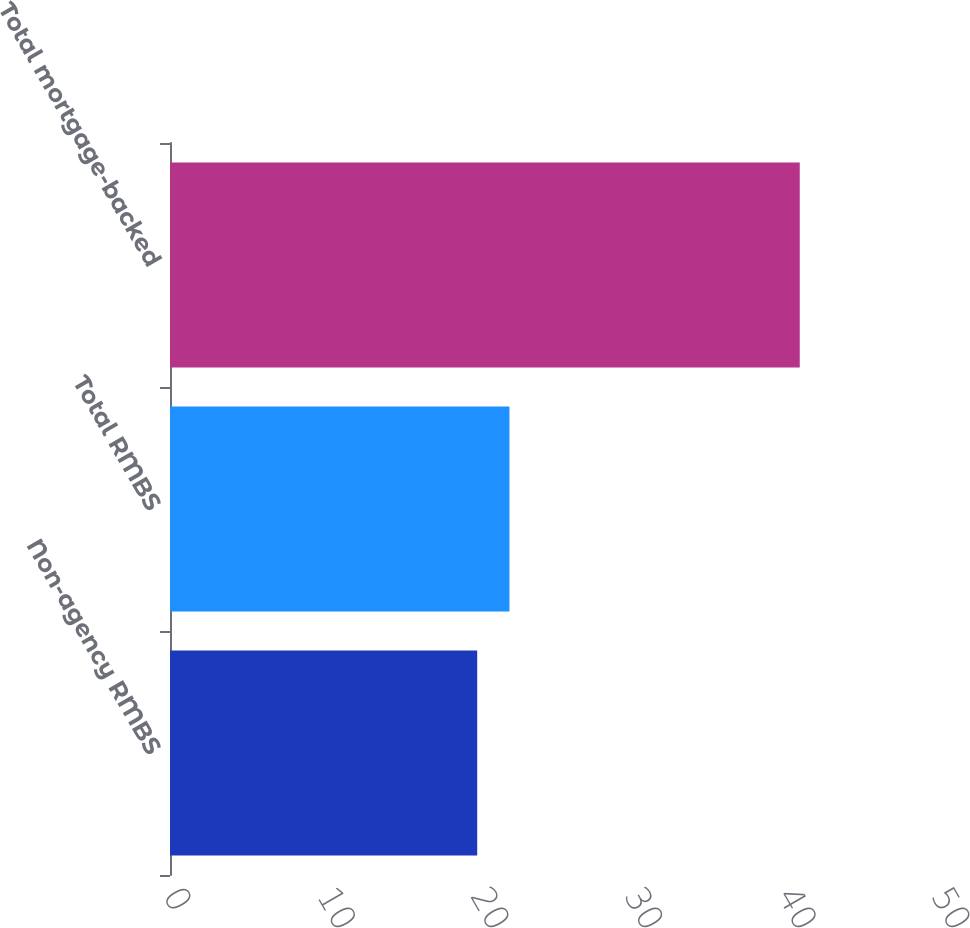Convert chart. <chart><loc_0><loc_0><loc_500><loc_500><bar_chart><fcel>Non-agency RMBS<fcel>Total RMBS<fcel>Total mortgage-backed<nl><fcel>20<fcel>22.1<fcel>41<nl></chart> 